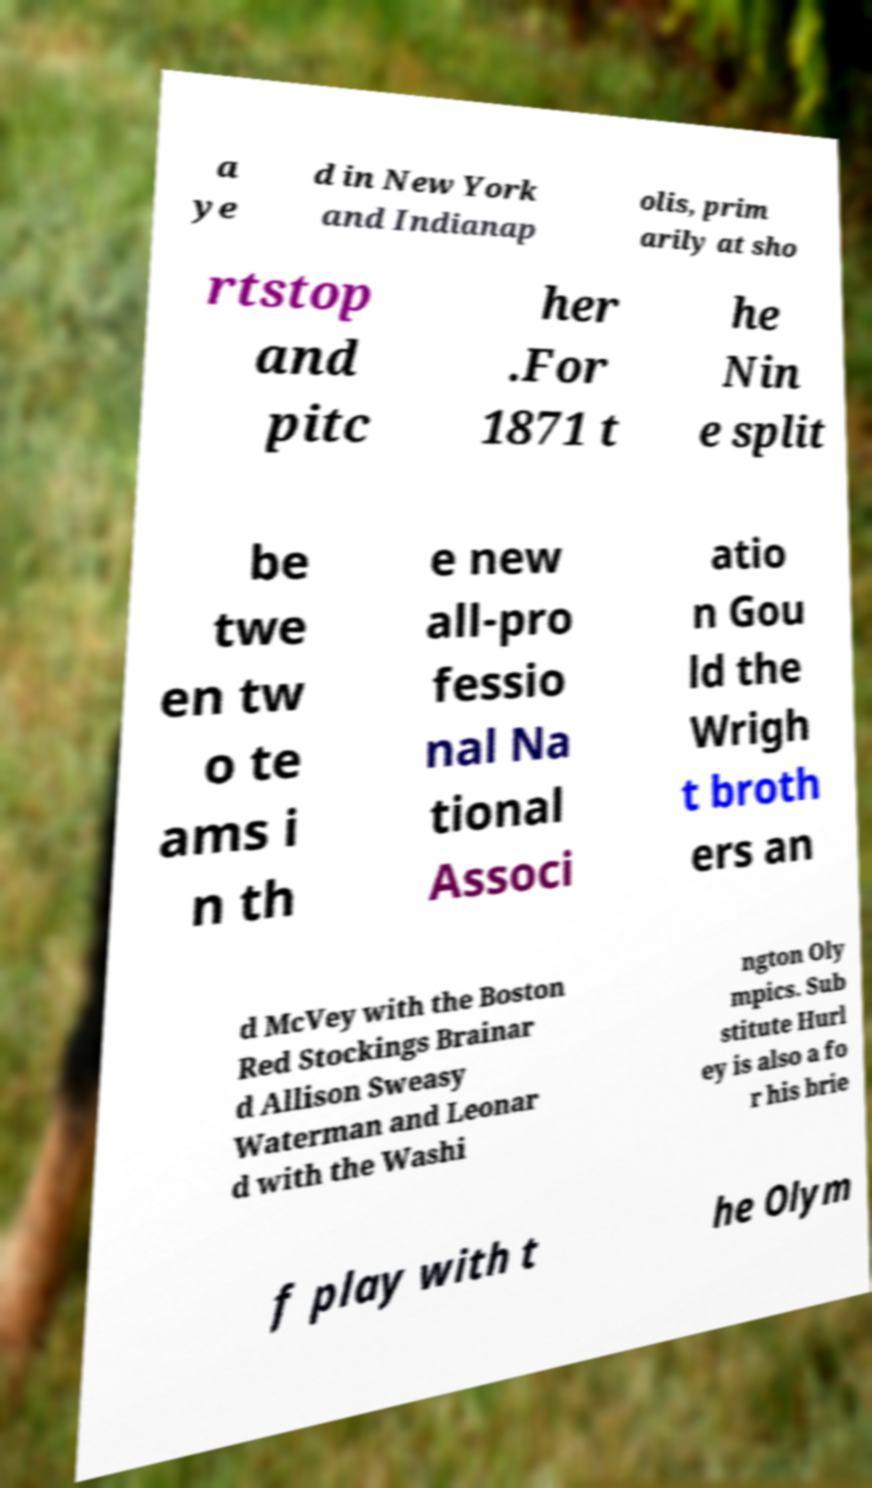Please identify and transcribe the text found in this image. a ye d in New York and Indianap olis, prim arily at sho rtstop and pitc her .For 1871 t he Nin e split be twe en tw o te ams i n th e new all-pro fessio nal Na tional Associ atio n Gou ld the Wrigh t broth ers an d McVey with the Boston Red Stockings Brainar d Allison Sweasy Waterman and Leonar d with the Washi ngton Oly mpics. Sub stitute Hurl ey is also a fo r his brie f play with t he Olym 